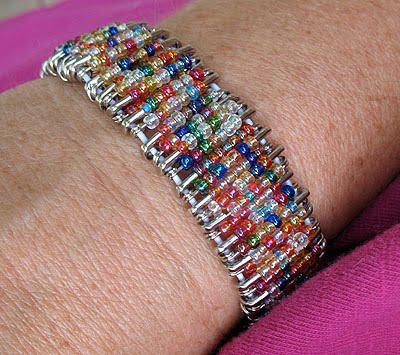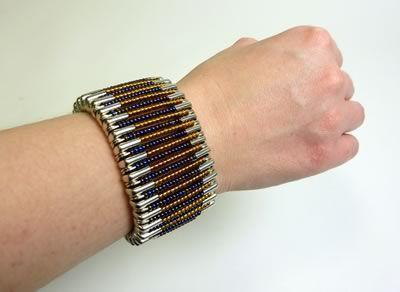The first image is the image on the left, the second image is the image on the right. Examine the images to the left and right. Is the description "A bracelet has at least three different colored beads." accurate? Answer yes or no. Yes. 